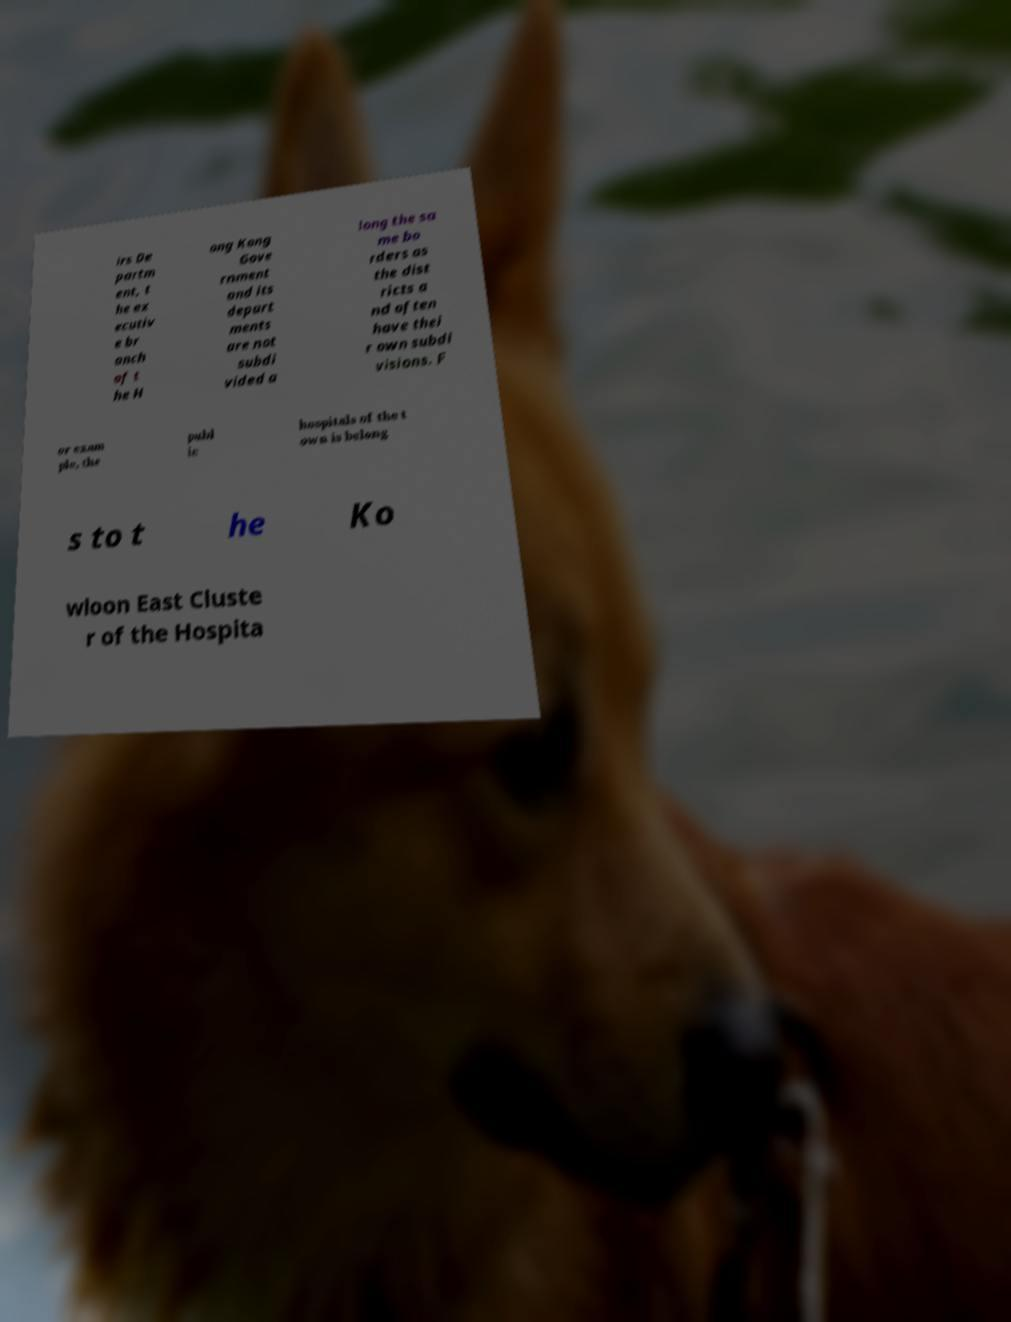Could you extract and type out the text from this image? irs De partm ent, t he ex ecutiv e br anch of t he H ong Kong Gove rnment and its depart ments are not subdi vided a long the sa me bo rders as the dist ricts a nd often have thei r own subdi visions. F or exam ple, the publ ic hospitals of the t own is belong s to t he Ko wloon East Cluste r of the Hospita 